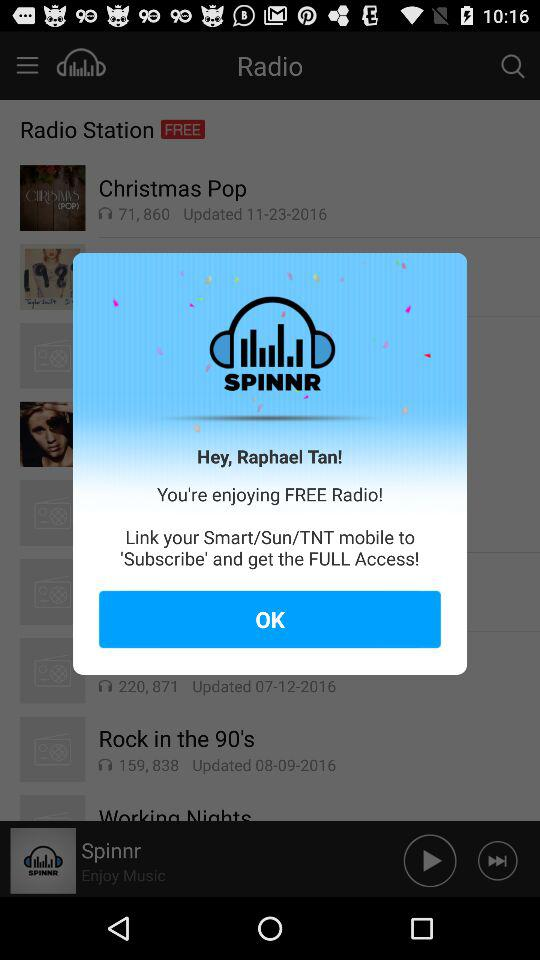How can we get full access to the application? You can get full access to the application by linking your Smart/Sun/TNT mobile to "Subscribe". 